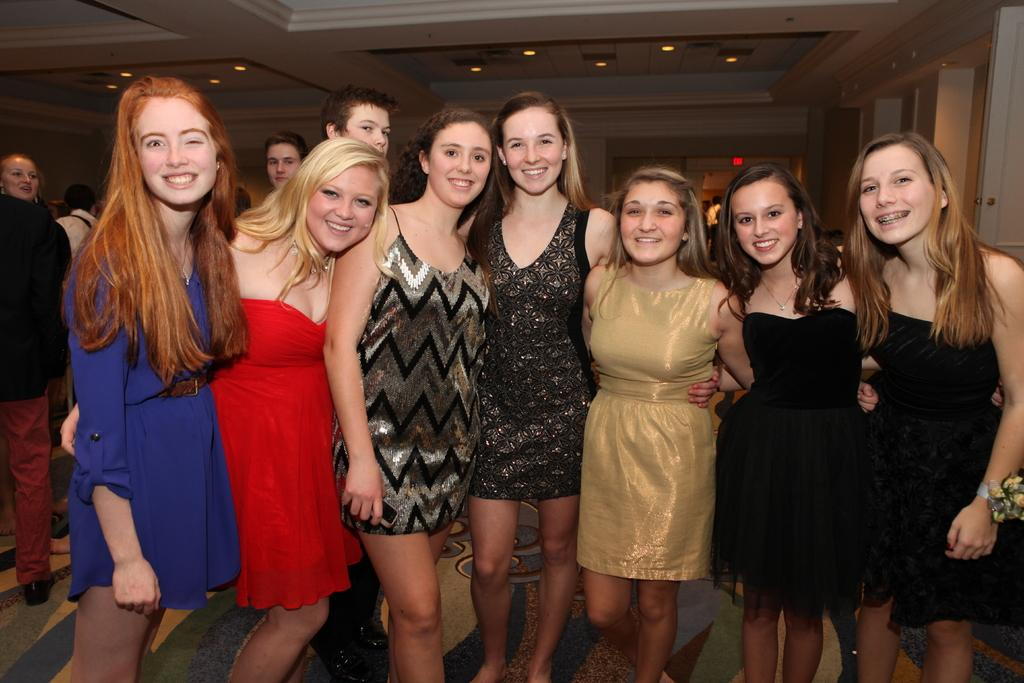How many people are in the image? There is a group of people in the image. What are the people in the image doing? The people are standing in the image. Can you describe the facial expressions of some people in the group? Some people in the group are smiling. What can be seen in the background of the image? There are lights visible in the background of the image. What type of guitar can be heard playing in the background of the image? There is no guitar or sound present in the image; it is a still photograph. 